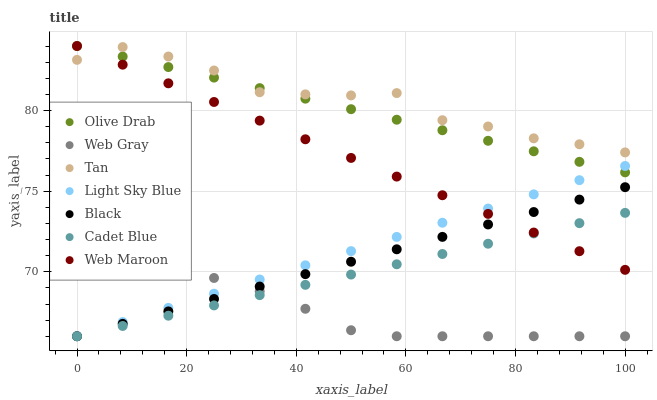Does Web Gray have the minimum area under the curve?
Answer yes or no. Yes. Does Tan have the maximum area under the curve?
Answer yes or no. Yes. Does Web Maroon have the minimum area under the curve?
Answer yes or no. No. Does Web Maroon have the maximum area under the curve?
Answer yes or no. No. Is Web Maroon the smoothest?
Answer yes or no. Yes. Is Tan the roughest?
Answer yes or no. Yes. Is Web Gray the smoothest?
Answer yes or no. No. Is Web Gray the roughest?
Answer yes or no. No. Does Cadet Blue have the lowest value?
Answer yes or no. Yes. Does Web Maroon have the lowest value?
Answer yes or no. No. Does Olive Drab have the highest value?
Answer yes or no. Yes. Does Web Gray have the highest value?
Answer yes or no. No. Is Web Gray less than Tan?
Answer yes or no. Yes. Is Web Maroon greater than Web Gray?
Answer yes or no. Yes. Does Cadet Blue intersect Light Sky Blue?
Answer yes or no. Yes. Is Cadet Blue less than Light Sky Blue?
Answer yes or no. No. Is Cadet Blue greater than Light Sky Blue?
Answer yes or no. No. Does Web Gray intersect Tan?
Answer yes or no. No. 